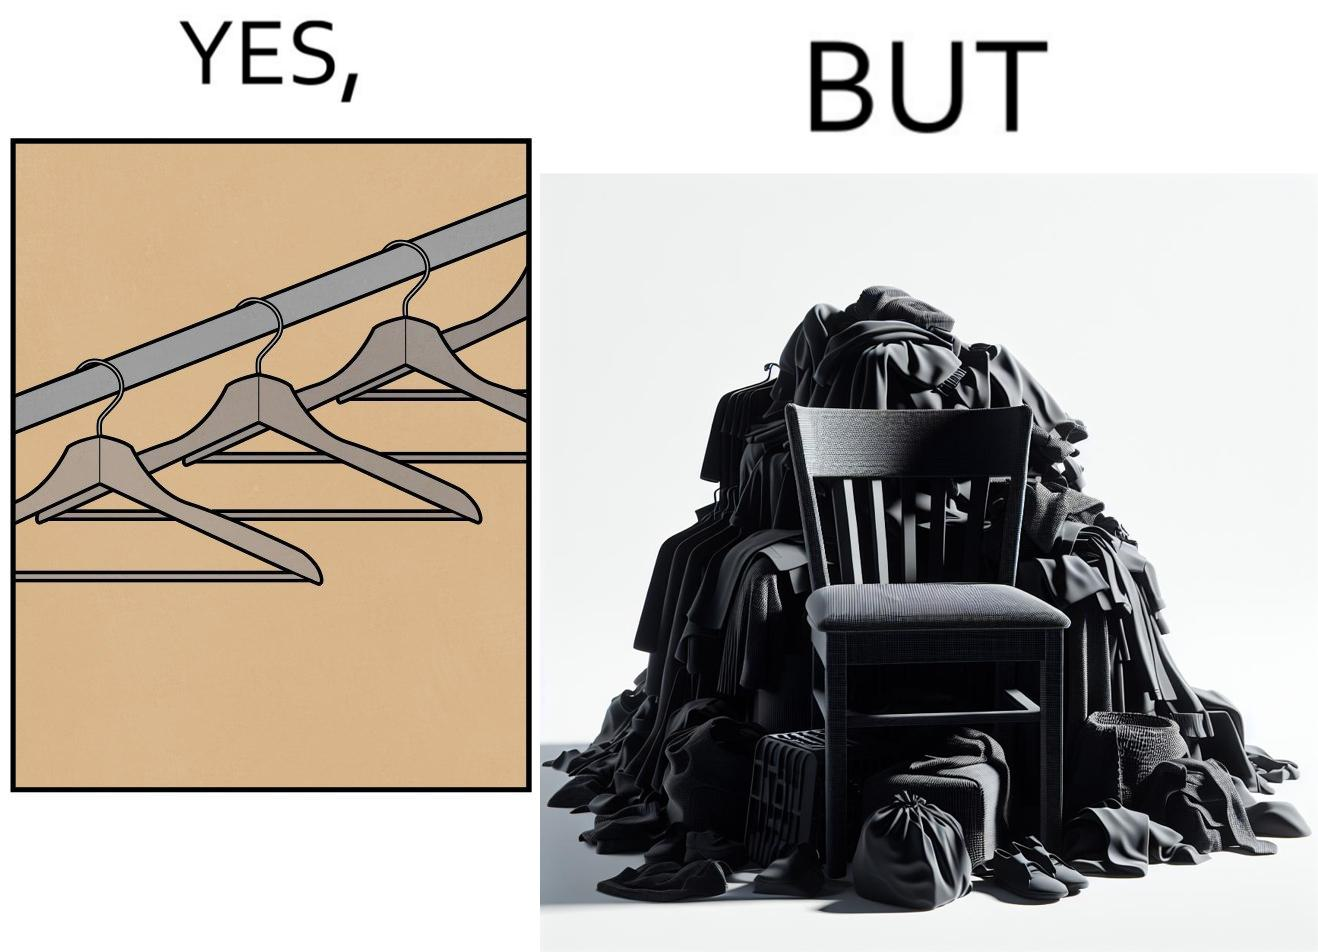What does this image depict? the image highlights irony when people make expensive and fancy wardrobes just to end up stacking all the clothes on a chair 